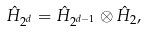Convert formula to latex. <formula><loc_0><loc_0><loc_500><loc_500>\hat { H } _ { 2 ^ { d } } = \hat { H } _ { 2 ^ { d - 1 } } \otimes \hat { H } _ { 2 } ,</formula> 